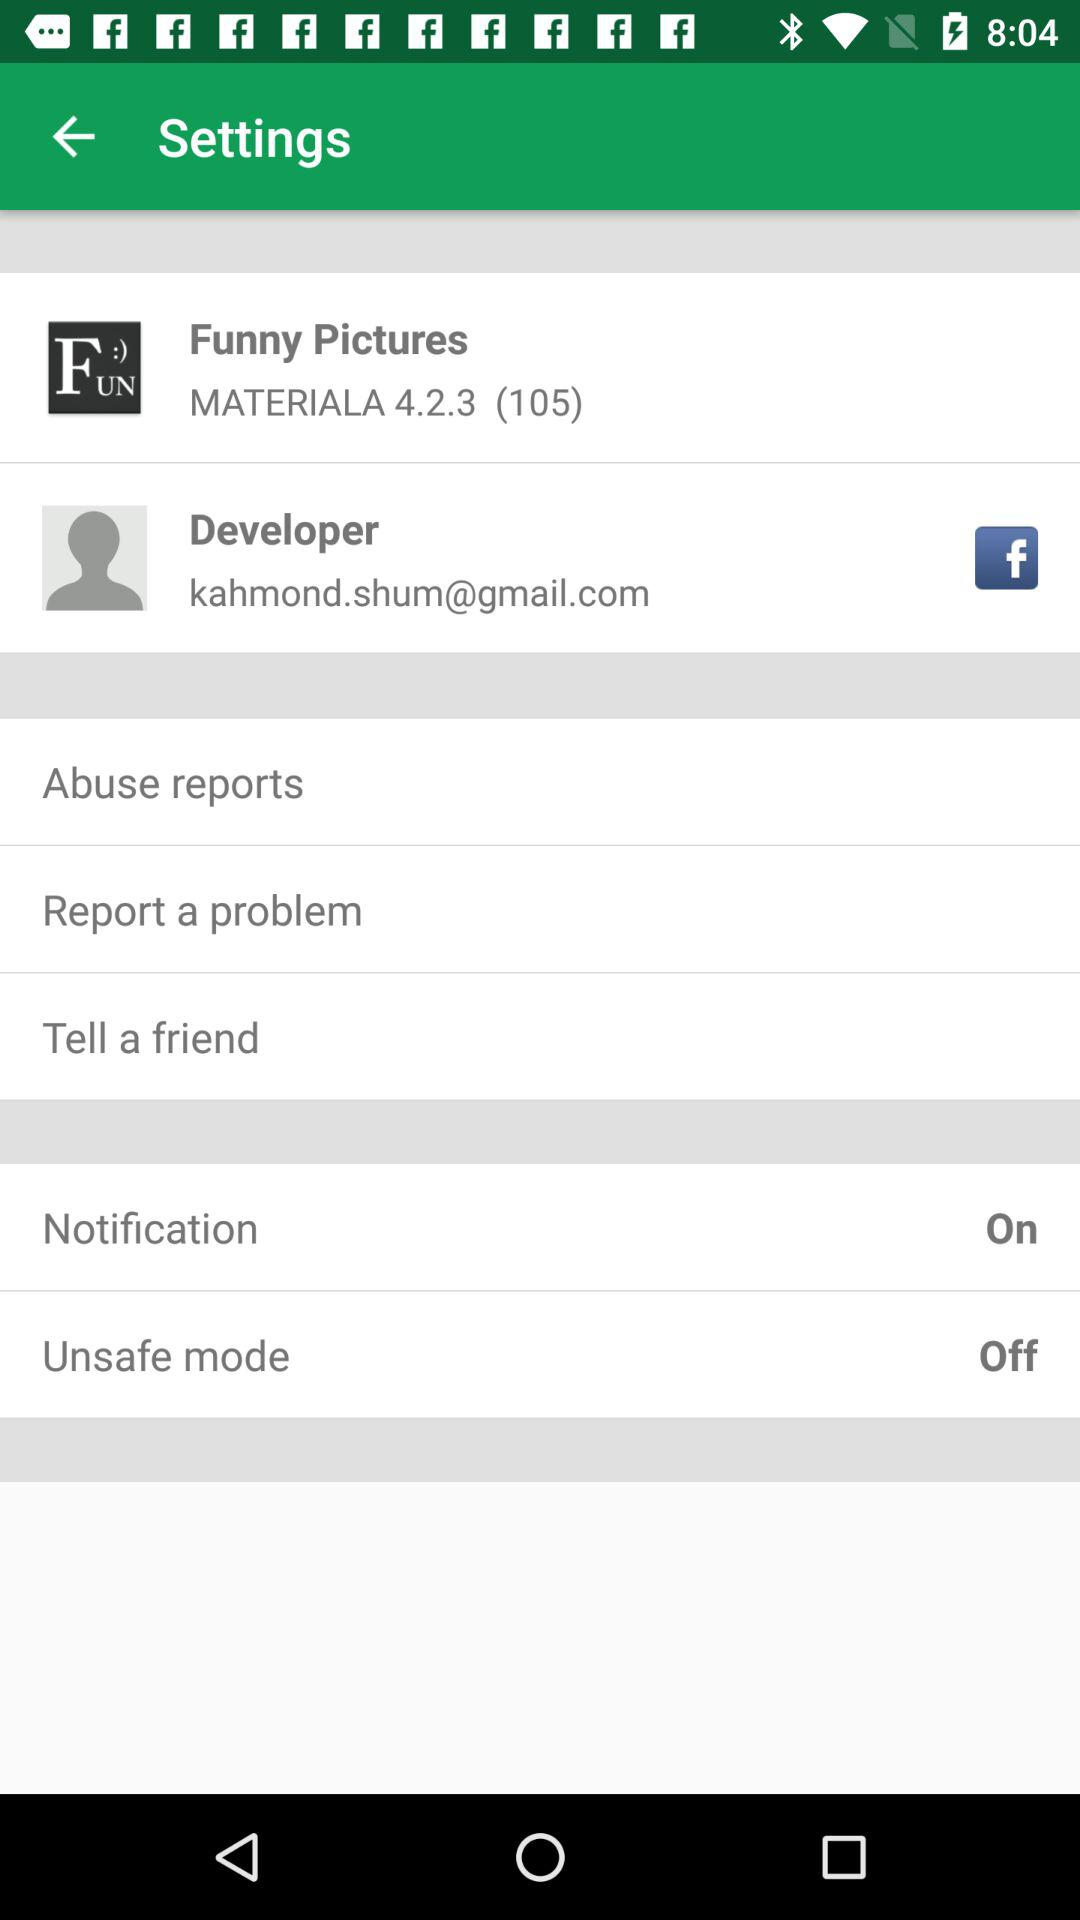What is the status of the "Unsafe mode"? Th status is "off". 